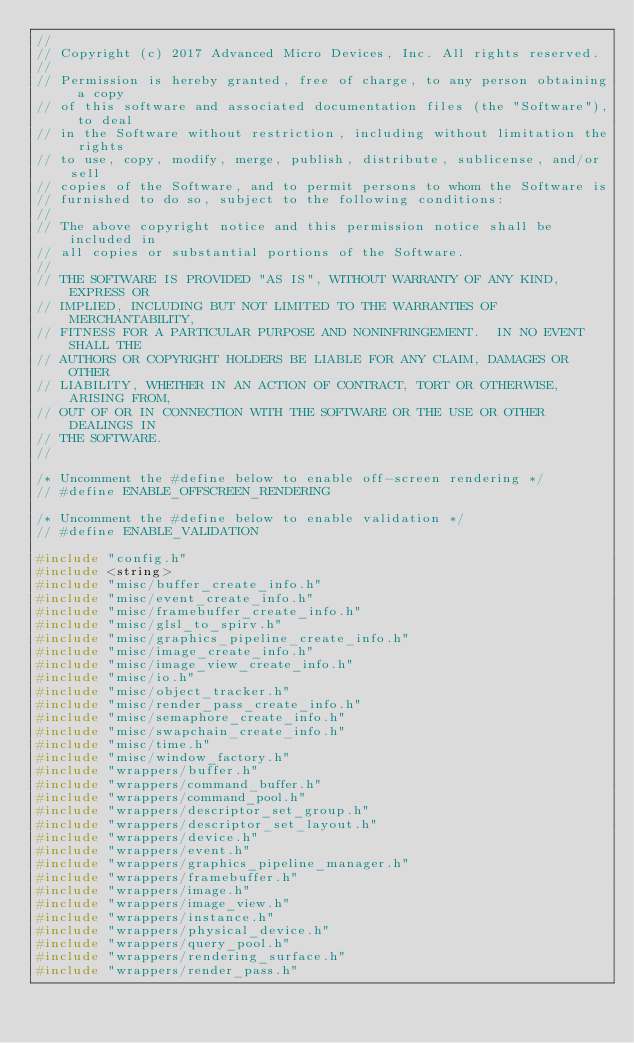Convert code to text. <code><loc_0><loc_0><loc_500><loc_500><_C++_>//
// Copyright (c) 2017 Advanced Micro Devices, Inc. All rights reserved.
//
// Permission is hereby granted, free of charge, to any person obtaining a copy
// of this software and associated documentation files (the "Software"), to deal
// in the Software without restriction, including without limitation the rights
// to use, copy, modify, merge, publish, distribute, sublicense, and/or sell
// copies of the Software, and to permit persons to whom the Software is
// furnished to do so, subject to the following conditions:
//
// The above copyright notice and this permission notice shall be included in
// all copies or substantial portions of the Software.
//
// THE SOFTWARE IS PROVIDED "AS IS", WITHOUT WARRANTY OF ANY KIND, EXPRESS OR
// IMPLIED, INCLUDING BUT NOT LIMITED TO THE WARRANTIES OF MERCHANTABILITY,
// FITNESS FOR A PARTICULAR PURPOSE AND NONINFRINGEMENT.  IN NO EVENT SHALL THE
// AUTHORS OR COPYRIGHT HOLDERS BE LIABLE FOR ANY CLAIM, DAMAGES OR OTHER
// LIABILITY, WHETHER IN AN ACTION OF CONTRACT, TORT OR OTHERWISE, ARISING FROM,
// OUT OF OR IN CONNECTION WITH THE SOFTWARE OR THE USE OR OTHER DEALINGS IN
// THE SOFTWARE.
//

/* Uncomment the #define below to enable off-screen rendering */
// #define ENABLE_OFFSCREEN_RENDERING

/* Uncomment the #define below to enable validation */
// #define ENABLE_VALIDATION

#include "config.h"
#include <string>
#include "misc/buffer_create_info.h"
#include "misc/event_create_info.h"
#include "misc/framebuffer_create_info.h"
#include "misc/glsl_to_spirv.h"
#include "misc/graphics_pipeline_create_info.h"
#include "misc/image_create_info.h"
#include "misc/image_view_create_info.h"
#include "misc/io.h"
#include "misc/object_tracker.h"
#include "misc/render_pass_create_info.h"
#include "misc/semaphore_create_info.h"
#include "misc/swapchain_create_info.h"
#include "misc/time.h"
#include "misc/window_factory.h"
#include "wrappers/buffer.h"
#include "wrappers/command_buffer.h"
#include "wrappers/command_pool.h"
#include "wrappers/descriptor_set_group.h"
#include "wrappers/descriptor_set_layout.h"
#include "wrappers/device.h"
#include "wrappers/event.h"
#include "wrappers/graphics_pipeline_manager.h"
#include "wrappers/framebuffer.h"
#include "wrappers/image.h"
#include "wrappers/image_view.h"
#include "wrappers/instance.h"
#include "wrappers/physical_device.h"
#include "wrappers/query_pool.h"
#include "wrappers/rendering_surface.h"
#include "wrappers/render_pass.h"</code> 